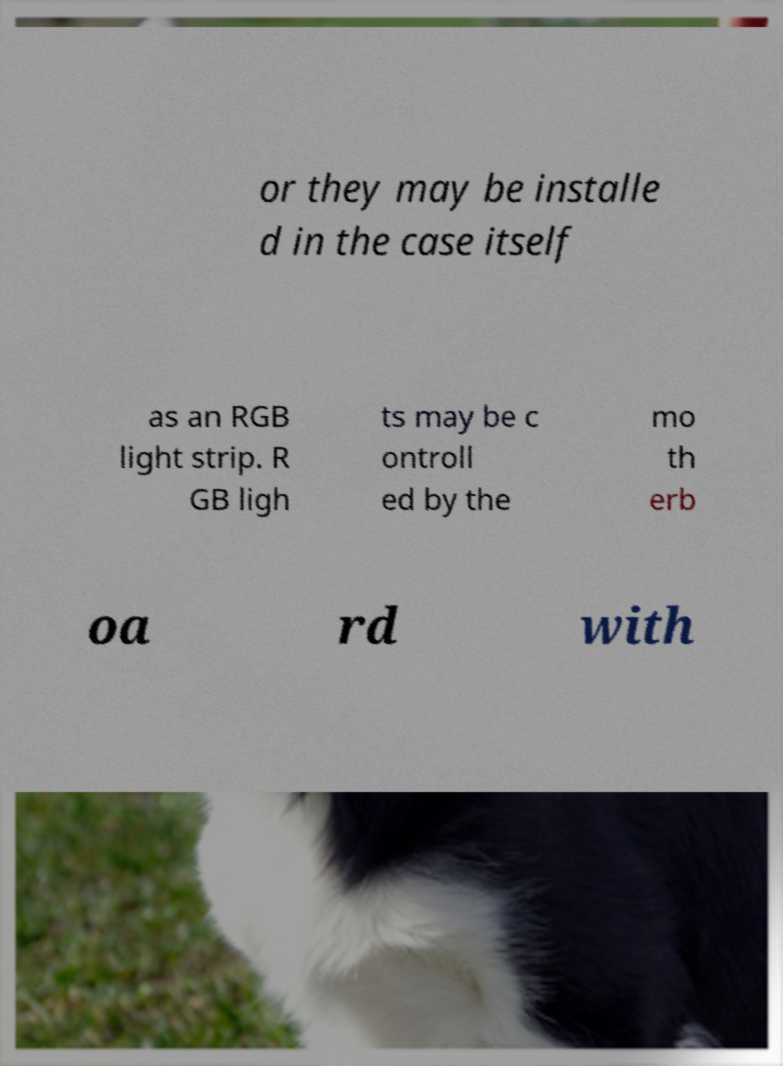I need the written content from this picture converted into text. Can you do that? or they may be installe d in the case itself as an RGB light strip. R GB ligh ts may be c ontroll ed by the mo th erb oa rd with 